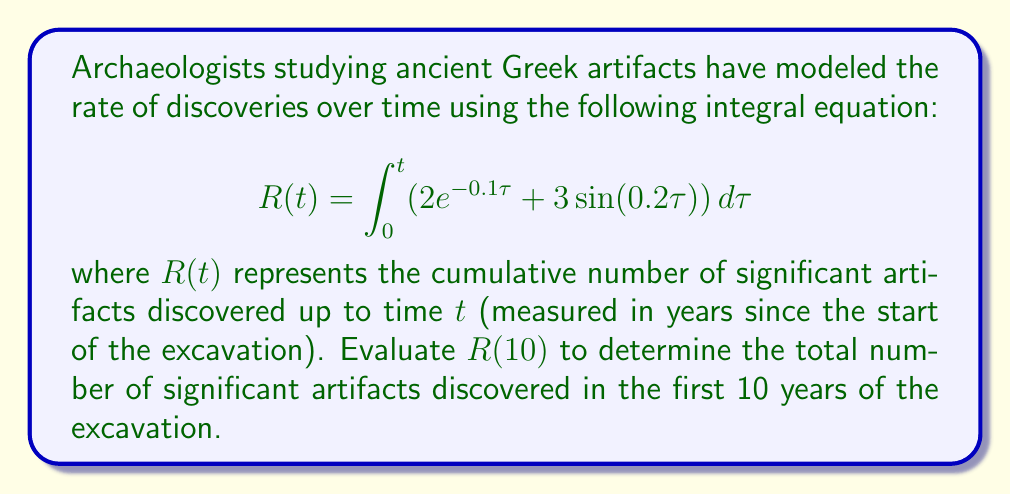Can you solve this math problem? To solve this problem, we need to evaluate the integral from 0 to 10:

1) First, let's split the integral into two parts:
   $$R(10) = \int_0^{10} 2e^{-0.1\tau} d\tau + \int_0^{10} 3\sin(0.2\tau) d\tau$$

2) For the first part:
   $$\int_0^{10} 2e^{-0.1\tau} d\tau = -20e^{-0.1\tau} \Big|_0^{10}$$
   $$= -20(e^{-1} - 1) \approx 7.3575$$

3) For the second part:
   $$\int_0^{10} 3\sin(0.2\tau) d\tau = -15\cos(0.2\tau) \Big|_0^{10}$$
   $$= -15(\cos(2) - 1) \approx 13.9734$$

4) Adding the results from steps 2 and 3:
   $$R(10) \approx 7.3575 + 13.9734 \approx 21.3309$$

5) Since we're dealing with discrete artifacts, we round to the nearest whole number:
   $$R(10) \approx 21$$
Answer: 21 artifacts 